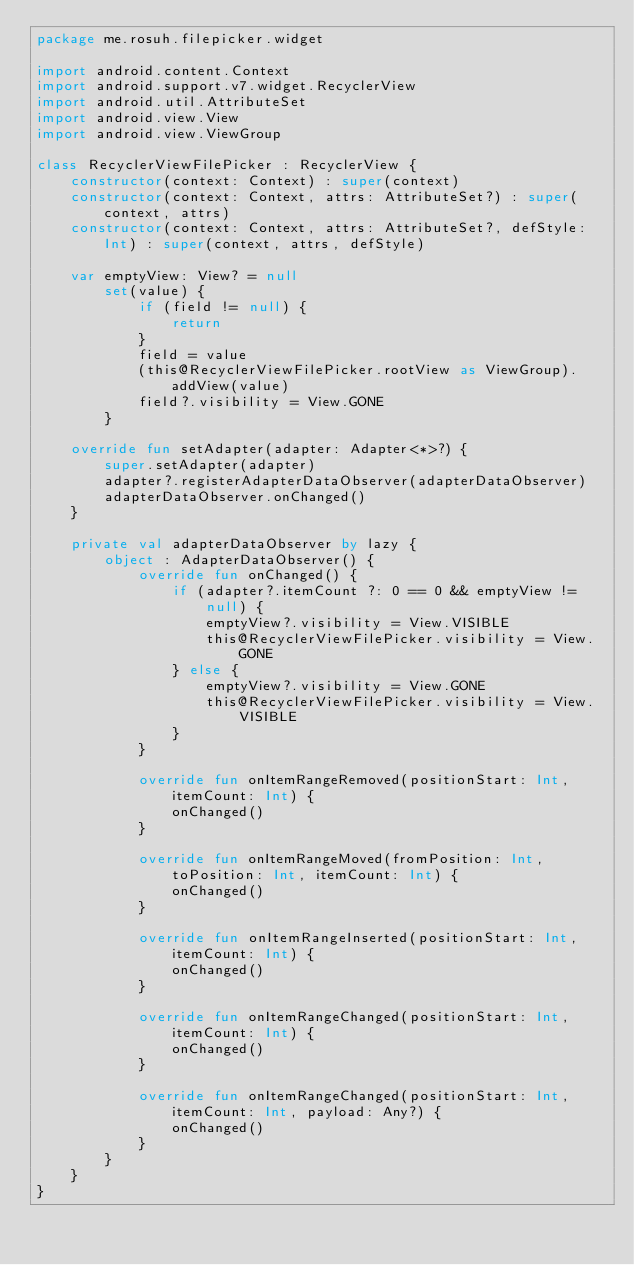<code> <loc_0><loc_0><loc_500><loc_500><_Kotlin_>package me.rosuh.filepicker.widget

import android.content.Context
import android.support.v7.widget.RecyclerView
import android.util.AttributeSet
import android.view.View
import android.view.ViewGroup

class RecyclerViewFilePicker : RecyclerView {
    constructor(context: Context) : super(context)
    constructor(context: Context, attrs: AttributeSet?) : super(context, attrs)
    constructor(context: Context, attrs: AttributeSet?, defStyle: Int) : super(context, attrs, defStyle)

    var emptyView: View? = null
        set(value) {
            if (field != null) {
                return
            }
            field = value
            (this@RecyclerViewFilePicker.rootView as ViewGroup).addView(value)
            field?.visibility = View.GONE
        }

    override fun setAdapter(adapter: Adapter<*>?) {
        super.setAdapter(adapter)
        adapter?.registerAdapterDataObserver(adapterDataObserver)
        adapterDataObserver.onChanged()
    }

    private val adapterDataObserver by lazy {
        object : AdapterDataObserver() {
            override fun onChanged() {
                if (adapter?.itemCount ?: 0 == 0 && emptyView != null) {
                    emptyView?.visibility = View.VISIBLE
                    this@RecyclerViewFilePicker.visibility = View.GONE
                } else {
                    emptyView?.visibility = View.GONE
                    this@RecyclerViewFilePicker.visibility = View.VISIBLE
                }
            }

            override fun onItemRangeRemoved(positionStart: Int, itemCount: Int) {
                onChanged()
            }

            override fun onItemRangeMoved(fromPosition: Int, toPosition: Int, itemCount: Int) {
                onChanged()
            }

            override fun onItemRangeInserted(positionStart: Int, itemCount: Int) {
                onChanged()
            }

            override fun onItemRangeChanged(positionStart: Int, itemCount: Int) {
                onChanged()
            }

            override fun onItemRangeChanged(positionStart: Int, itemCount: Int, payload: Any?) {
                onChanged()
            }
        }
    }
}</code> 